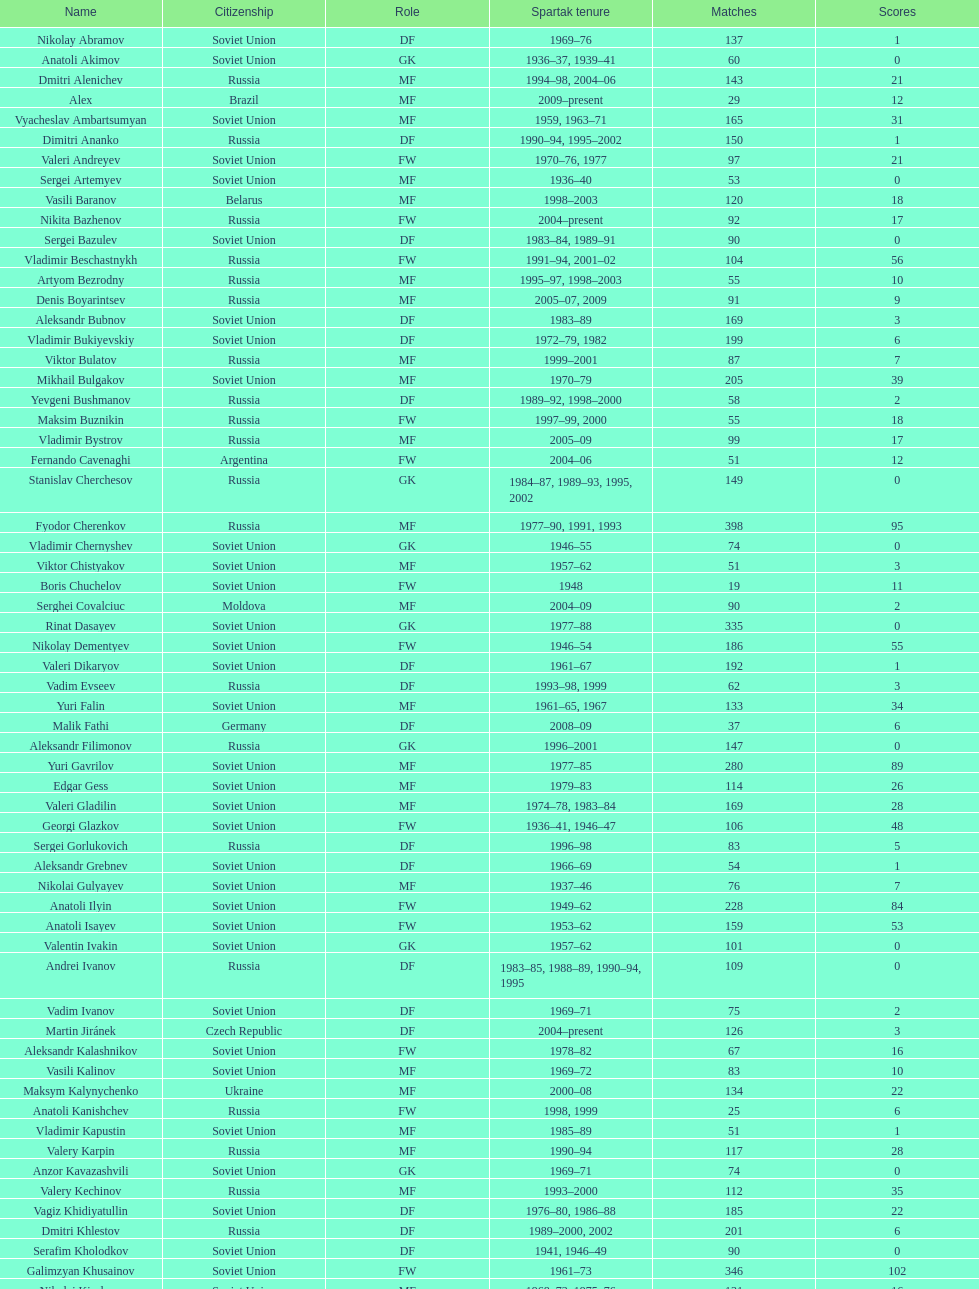Who had the highest number of appearances? Fyodor Cherenkov. 